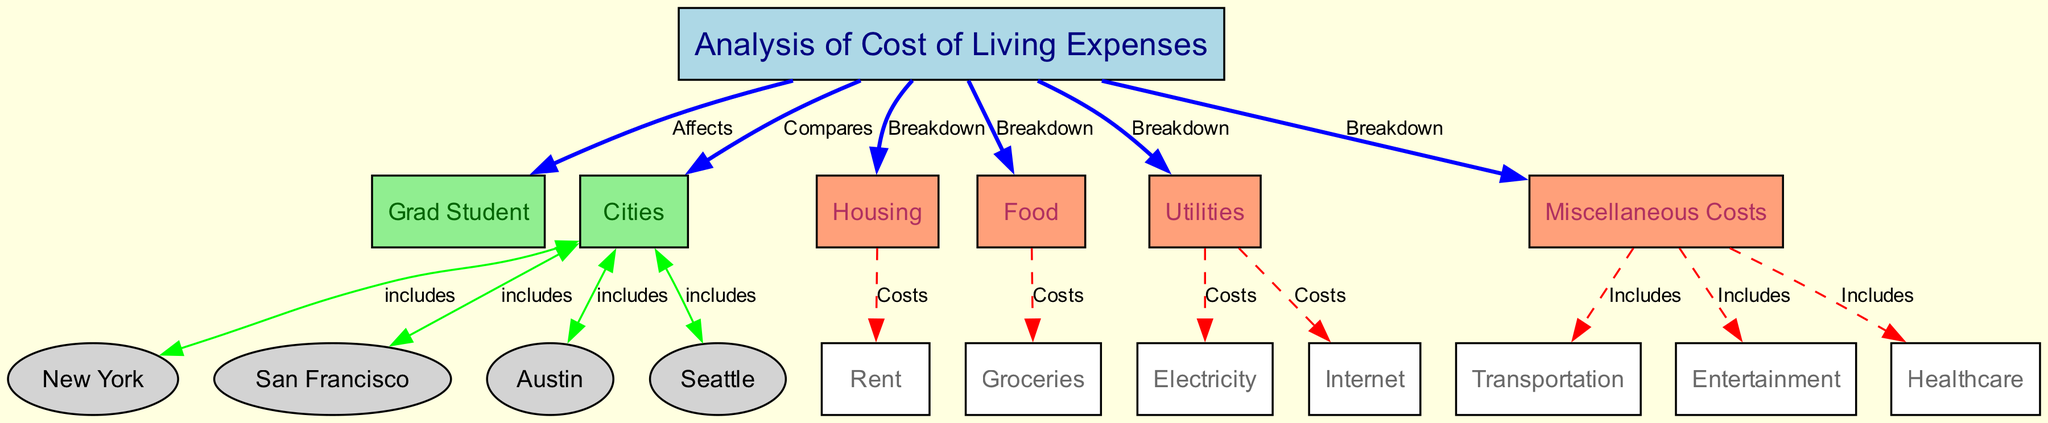What is the primary subject of the diagram? The diagram focuses on the "Analysis of Cost of Living Expenses" for grad students. This is indicated by the central node labeled "Analysis of Cost of Living Expenses."
Answer: Analysis of Cost of Living Expenses How many cities are included in the analysis? The diagram lists four cities: New York, San Francisco, Austin, and Seattle, indicated by the edges from the "Cities" node to each city node. Thus, there are four cities in total.
Answer: Four What categories are used to break down the cost of living? The costs are divided into four categories: Housing, Food, Utilities, and Miscellaneous Costs, as indicated by edges from the "Analysis of Cost of Living Expenses" node to each category node.
Answer: Housing, Food, Utilities, Miscellaneous Costs Which city's cost includes housing expenses? The edge connecting "Cities" to "New York" includes housing expenses as part of the cost analysis for that city. Additionally, all cities mentioned are likely included; however, the question asks specifically for one city.
Answer: New York What types of expenses are included in the "Miscellaneous Costs"? The "Miscellaneous Costs" category includes transportation, entertainment, and healthcare, as shown by the edges leading from the "Miscellaneous" node to these specific expenses.
Answer: Transportation, entertainment, healthcare Which category of expenses has a breakdown of rent? The "Housing" category has a breakdown specifically for rent, since the edge from "Housing" to "Rent" indicates this direct relationship.
Answer: Rent Explain the relationship between "Utilities" and what specific costs it covers. The "Utilities" node has connections to both "Electricity" and "Internet," indicating that these are the specific costs covered under the "Utilities" category as part of the cost of living analysis.
Answer: Electricity, Internet Which two cities might be the most expensive for grad students to live in? While the diagram does not provide specific values, one can reason that New York and San Francisco are generally known for high living costs. Both cities are included in the diagram and have a reputation for expensive housing and living conditions.
Answer: New York, San Francisco 